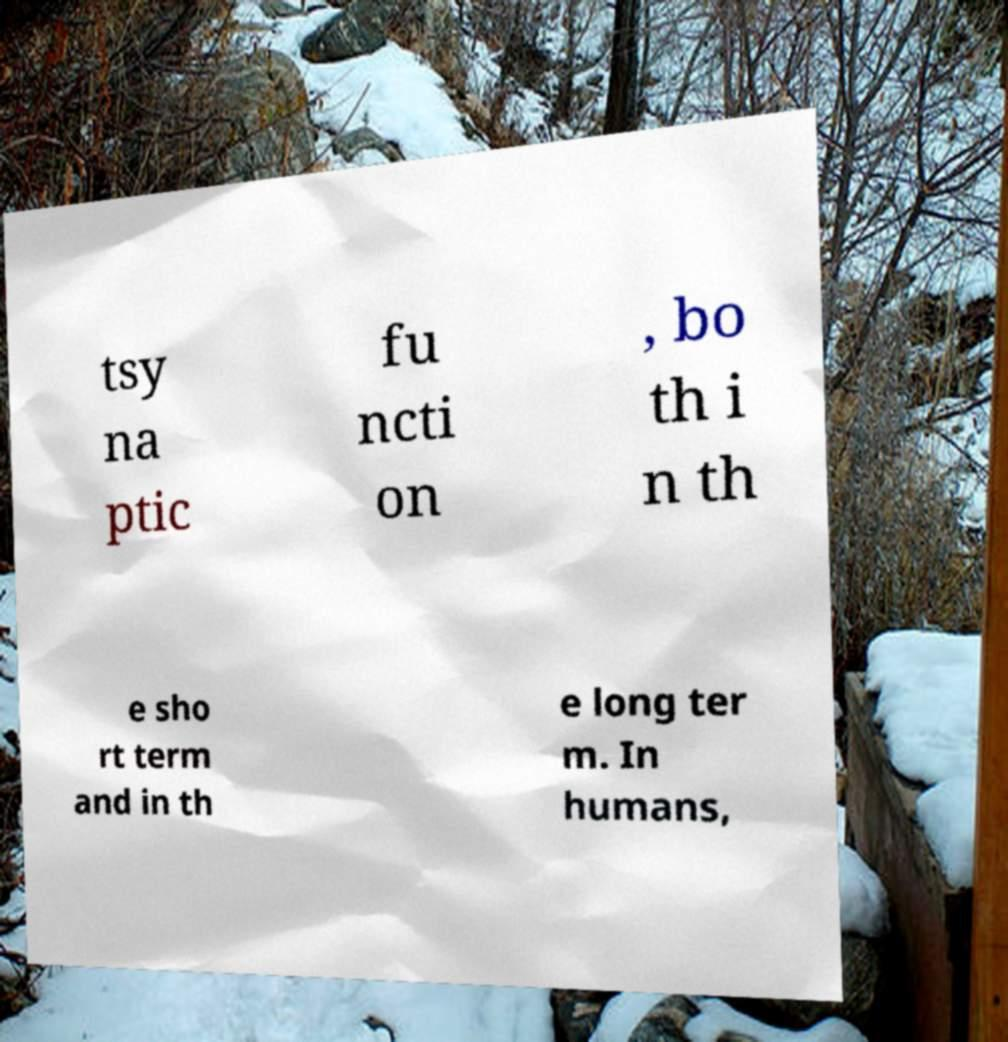Can you accurately transcribe the text from the provided image for me? tsy na ptic fu ncti on , bo th i n th e sho rt term and in th e long ter m. In humans, 